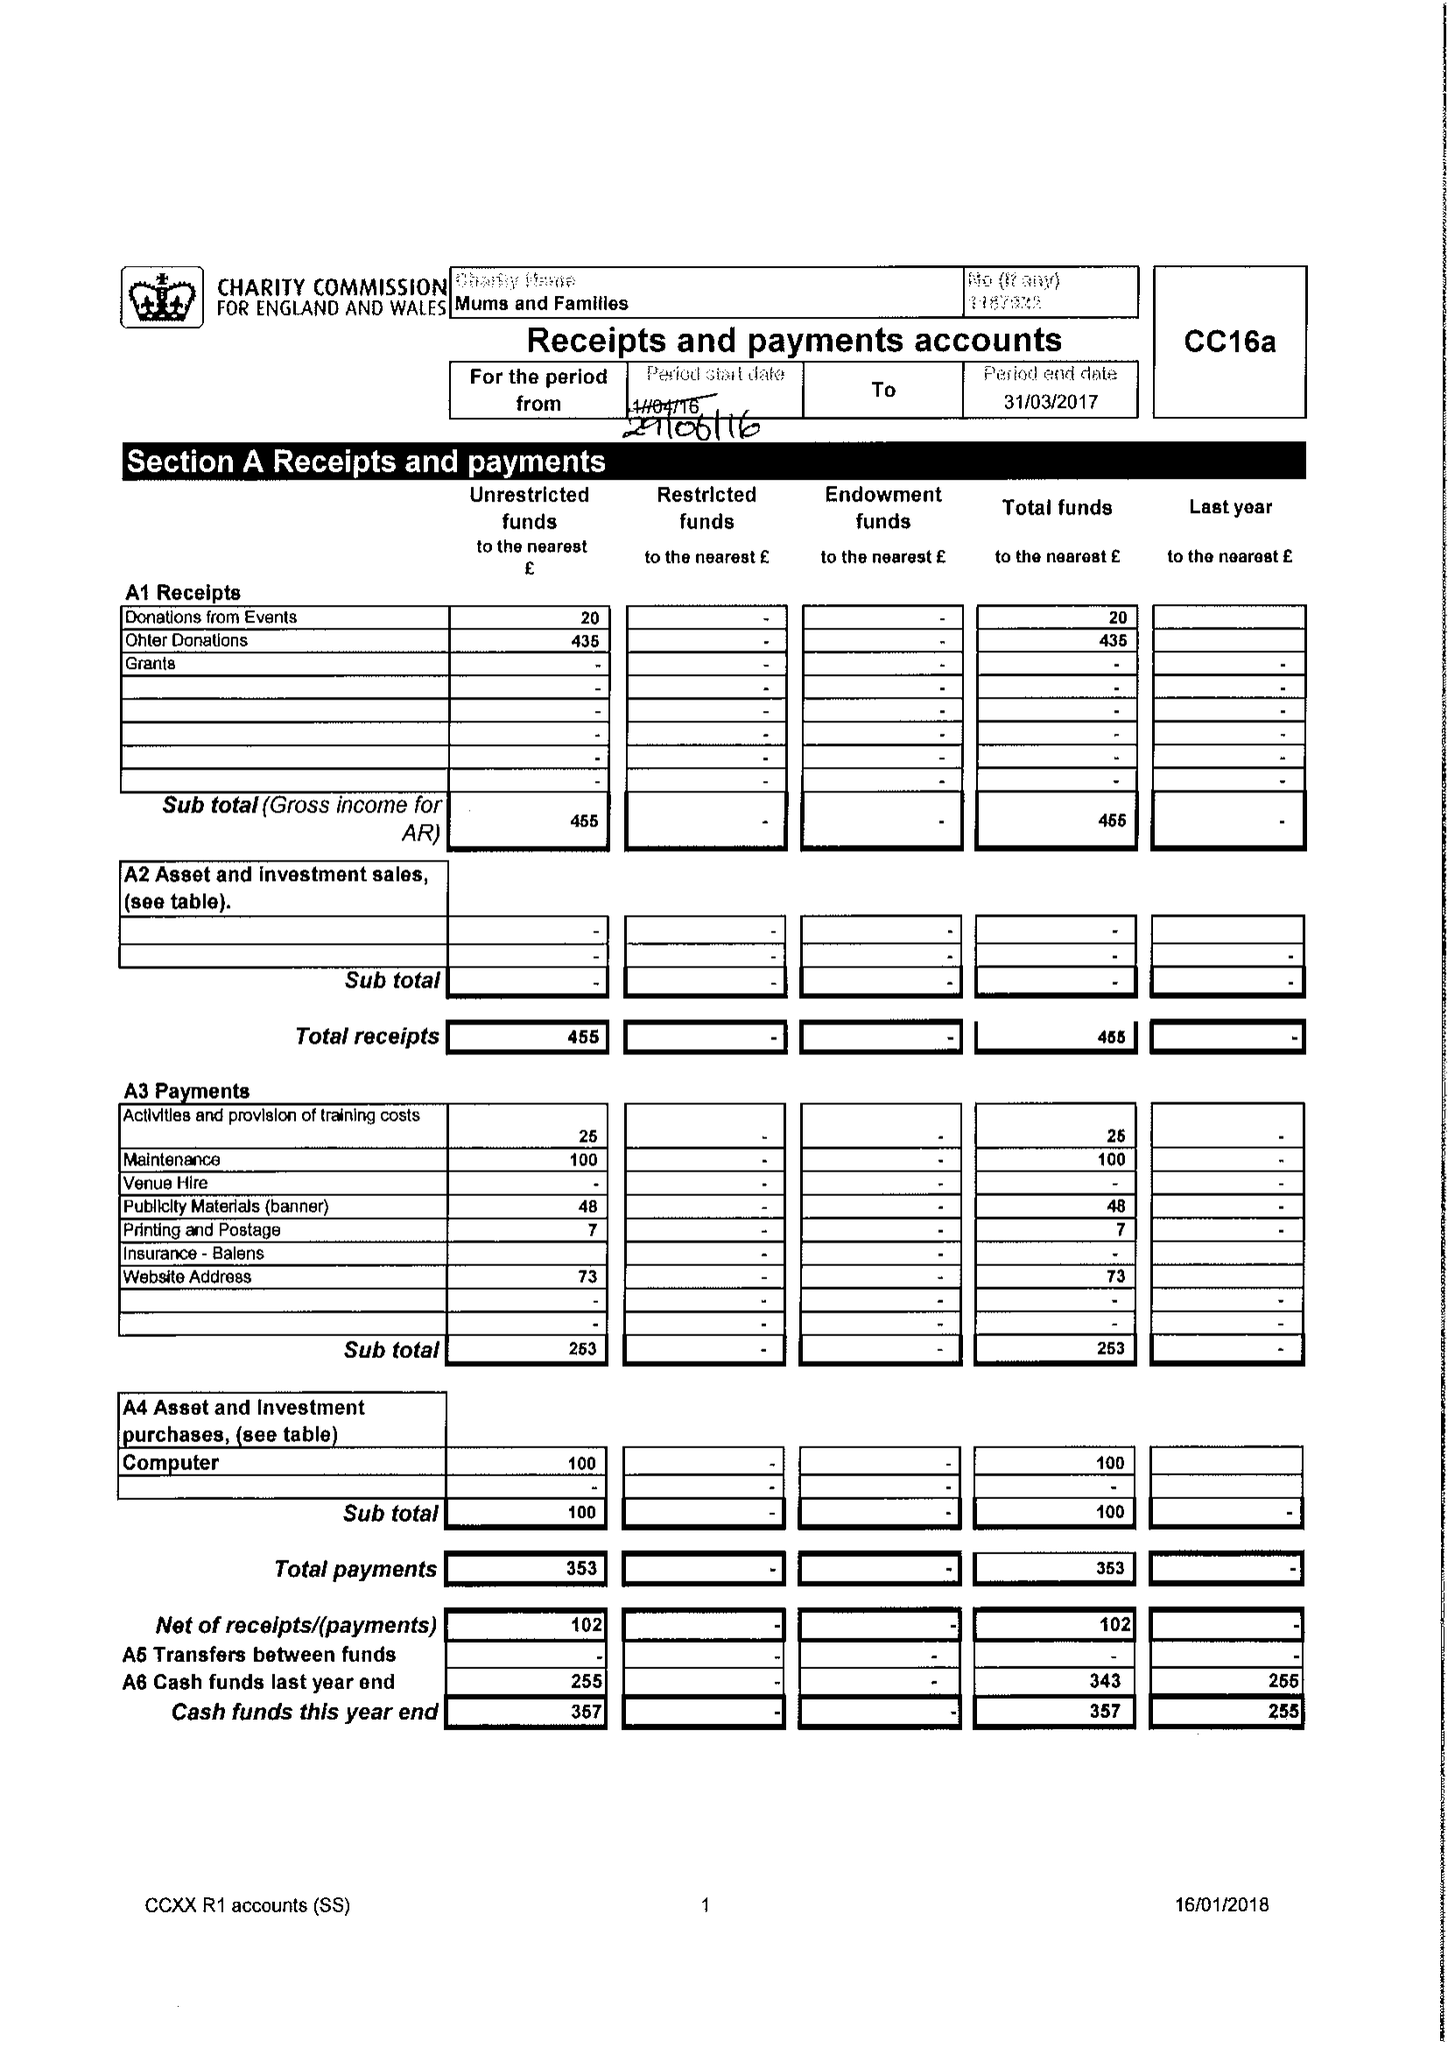What is the value for the charity_number?
Answer the question using a single word or phrase. 1167922 